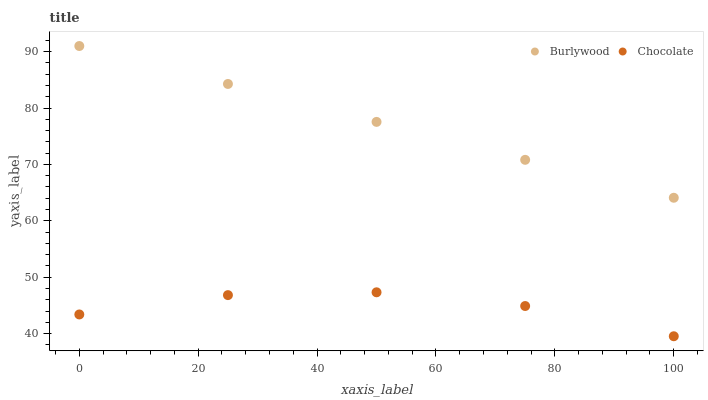Does Chocolate have the minimum area under the curve?
Answer yes or no. Yes. Does Burlywood have the maximum area under the curve?
Answer yes or no. Yes. Does Chocolate have the maximum area under the curve?
Answer yes or no. No. Is Burlywood the smoothest?
Answer yes or no. Yes. Is Chocolate the roughest?
Answer yes or no. Yes. Is Chocolate the smoothest?
Answer yes or no. No. Does Chocolate have the lowest value?
Answer yes or no. Yes. Does Burlywood have the highest value?
Answer yes or no. Yes. Does Chocolate have the highest value?
Answer yes or no. No. Is Chocolate less than Burlywood?
Answer yes or no. Yes. Is Burlywood greater than Chocolate?
Answer yes or no. Yes. Does Chocolate intersect Burlywood?
Answer yes or no. No. 